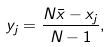Convert formula to latex. <formula><loc_0><loc_0><loc_500><loc_500>y _ { j } = \frac { N \bar { x } - x _ { j } } { N - 1 } ,</formula> 